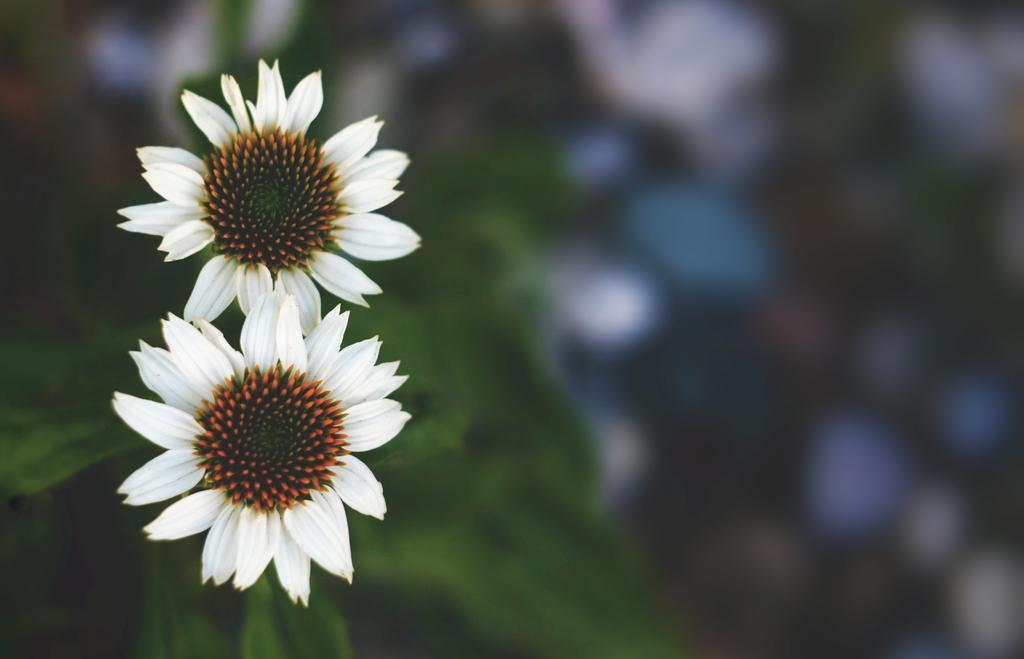In one or two sentences, can you explain what this image depicts? In this image we can see flowers and there are leaves. 